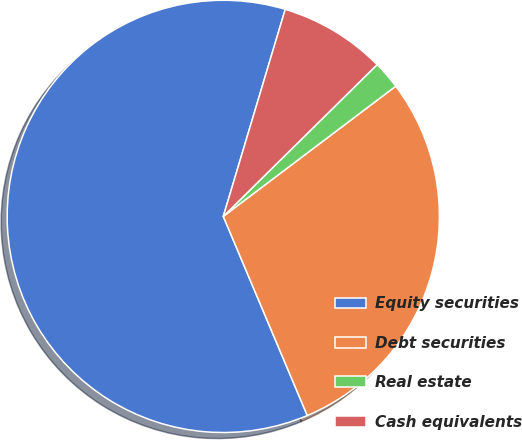<chart> <loc_0><loc_0><loc_500><loc_500><pie_chart><fcel>Equity securities<fcel>Debt securities<fcel>Real estate<fcel>Cash equivalents<nl><fcel>60.98%<fcel>28.94%<fcel>2.1%<fcel>7.98%<nl></chart> 